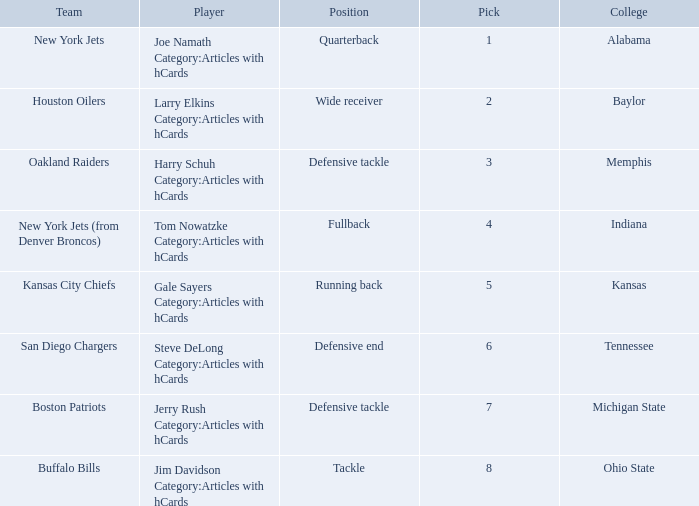Which player is from the College of Alabama? Joe Namath Category:Articles with hCards. 